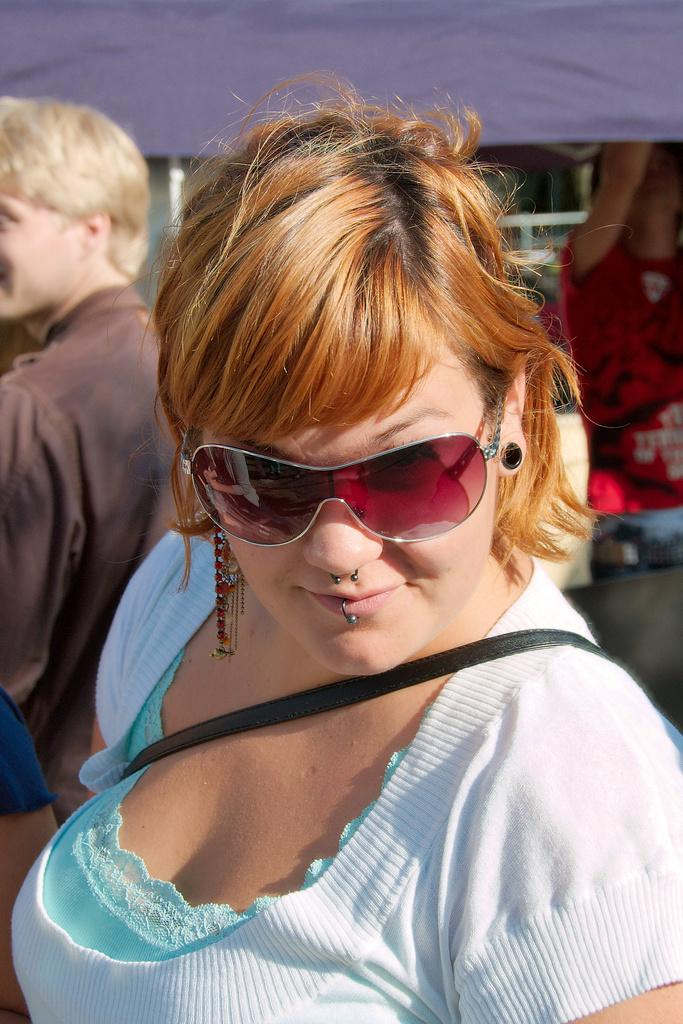How many people are in the image? There are persons in the image. Can you describe the woman in the front of the image? The woman in the front of the image is wearing goggles and a blue dress. What day of the week is depicted in the image? The provided facts do not mention any specific day of the week, so it cannot be determined from the image. 